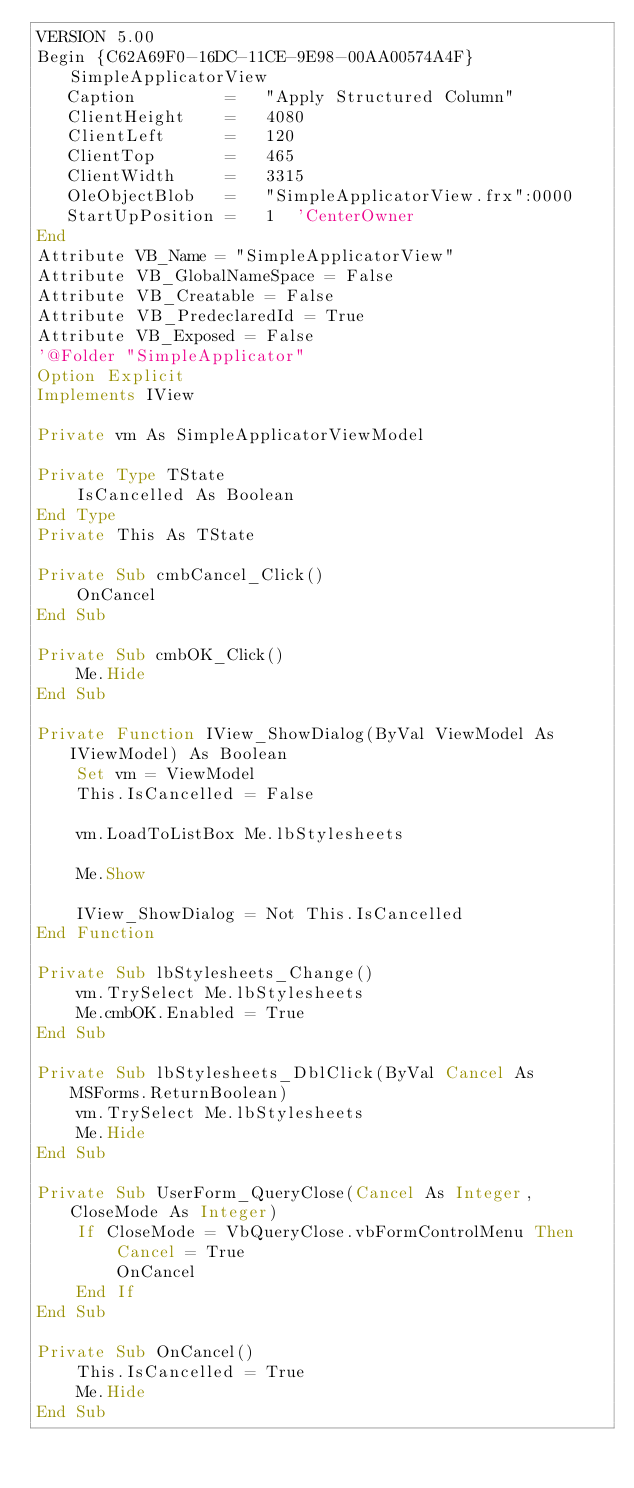<code> <loc_0><loc_0><loc_500><loc_500><_VisualBasic_>VERSION 5.00
Begin {C62A69F0-16DC-11CE-9E98-00AA00574A4F} SimpleApplicatorView 
   Caption         =   "Apply Structured Column"
   ClientHeight    =   4080
   ClientLeft      =   120
   ClientTop       =   465
   ClientWidth     =   3315
   OleObjectBlob   =   "SimpleApplicatorView.frx":0000
   StartUpPosition =   1  'CenterOwner
End
Attribute VB_Name = "SimpleApplicatorView"
Attribute VB_GlobalNameSpace = False
Attribute VB_Creatable = False
Attribute VB_PredeclaredId = True
Attribute VB_Exposed = False
'@Folder "SimpleApplicator"
Option Explicit
Implements IView

Private vm As SimpleApplicatorViewModel

Private Type TState
    IsCancelled As Boolean
End Type
Private This As TState

Private Sub cmbCancel_Click()
    OnCancel
End Sub

Private Sub cmbOK_Click()
    Me.Hide
End Sub

Private Function IView_ShowDialog(ByVal ViewModel As IViewModel) As Boolean
    Set vm = ViewModel
    This.IsCancelled = False
    
    vm.LoadToListBox Me.lbStylesheets
    
    Me.Show
    
    IView_ShowDialog = Not This.IsCancelled
End Function

Private Sub lbStylesheets_Change()
    vm.TrySelect Me.lbStylesheets
    Me.cmbOK.Enabled = True
End Sub

Private Sub lbStylesheets_DblClick(ByVal Cancel As MSForms.ReturnBoolean)
    vm.TrySelect Me.lbStylesheets
    Me.Hide
End Sub

Private Sub UserForm_QueryClose(Cancel As Integer, CloseMode As Integer)
    If CloseMode = VbQueryClose.vbFormControlMenu Then
        Cancel = True
        OnCancel
    End If
End Sub

Private Sub OnCancel()
    This.IsCancelled = True
    Me.Hide
End Sub
</code> 